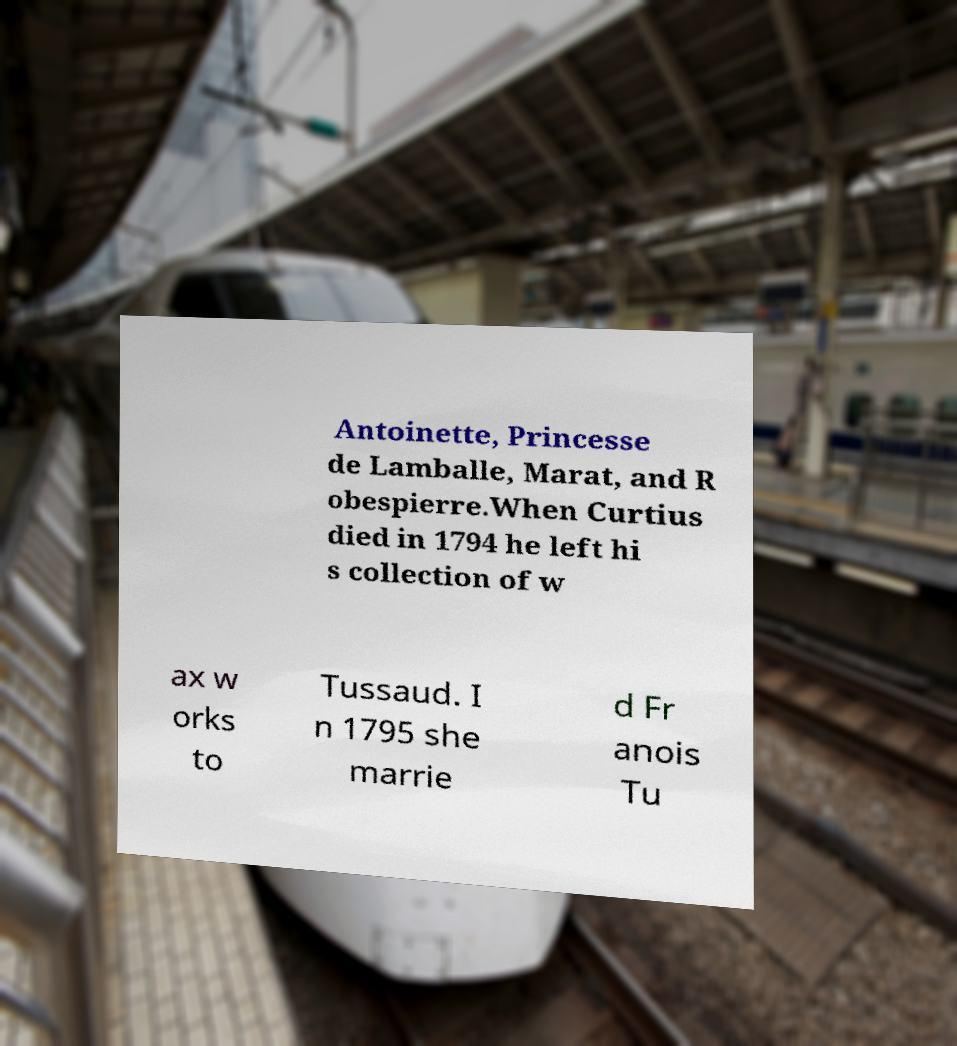For documentation purposes, I need the text within this image transcribed. Could you provide that? Antoinette, Princesse de Lamballe, Marat, and R obespierre.When Curtius died in 1794 he left hi s collection of w ax w orks to Tussaud. I n 1795 she marrie d Fr anois Tu 